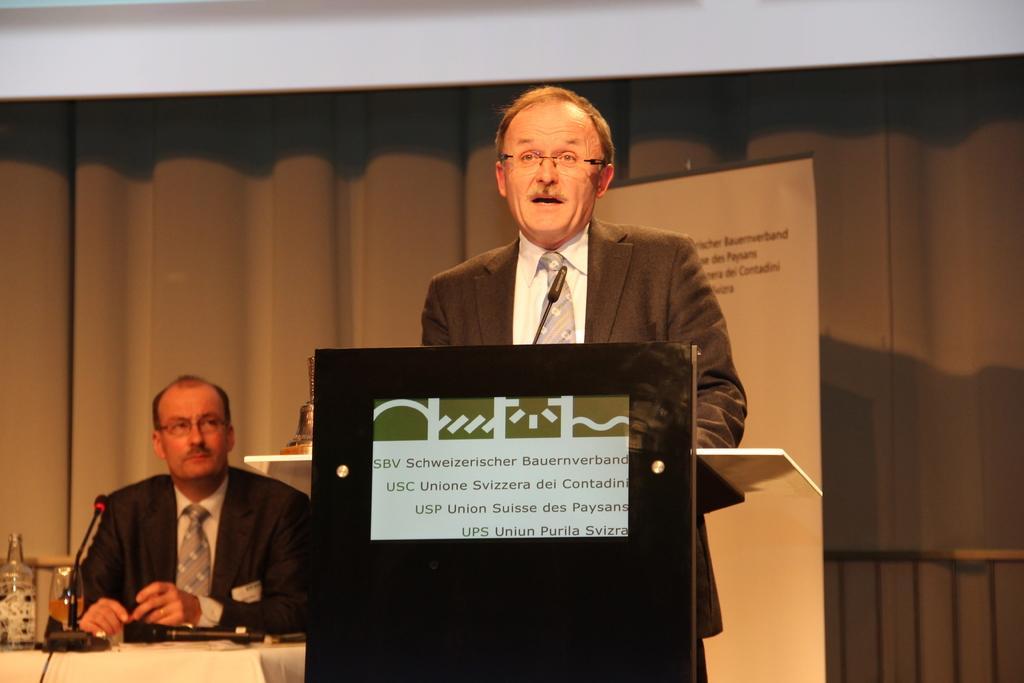How would you summarize this image in a sentence or two? In this image we can see a man is standing, he is wearing the suit, here is the podium, here is the hoarding, beside here a man is sitting, in front here is the table, and microphone on it. 